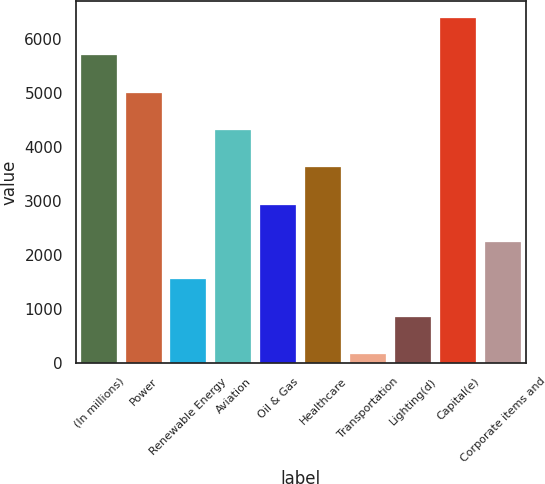<chart> <loc_0><loc_0><loc_500><loc_500><bar_chart><fcel>(In millions)<fcel>Power<fcel>Renewable Energy<fcel>Aviation<fcel>Oil & Gas<fcel>Healthcare<fcel>Transportation<fcel>Lighting(d)<fcel>Capital(e)<fcel>Corporate items and<nl><fcel>5692.4<fcel>5002.1<fcel>1550.6<fcel>4311.8<fcel>2931.2<fcel>3621.5<fcel>170<fcel>860.3<fcel>6382.7<fcel>2240.9<nl></chart> 